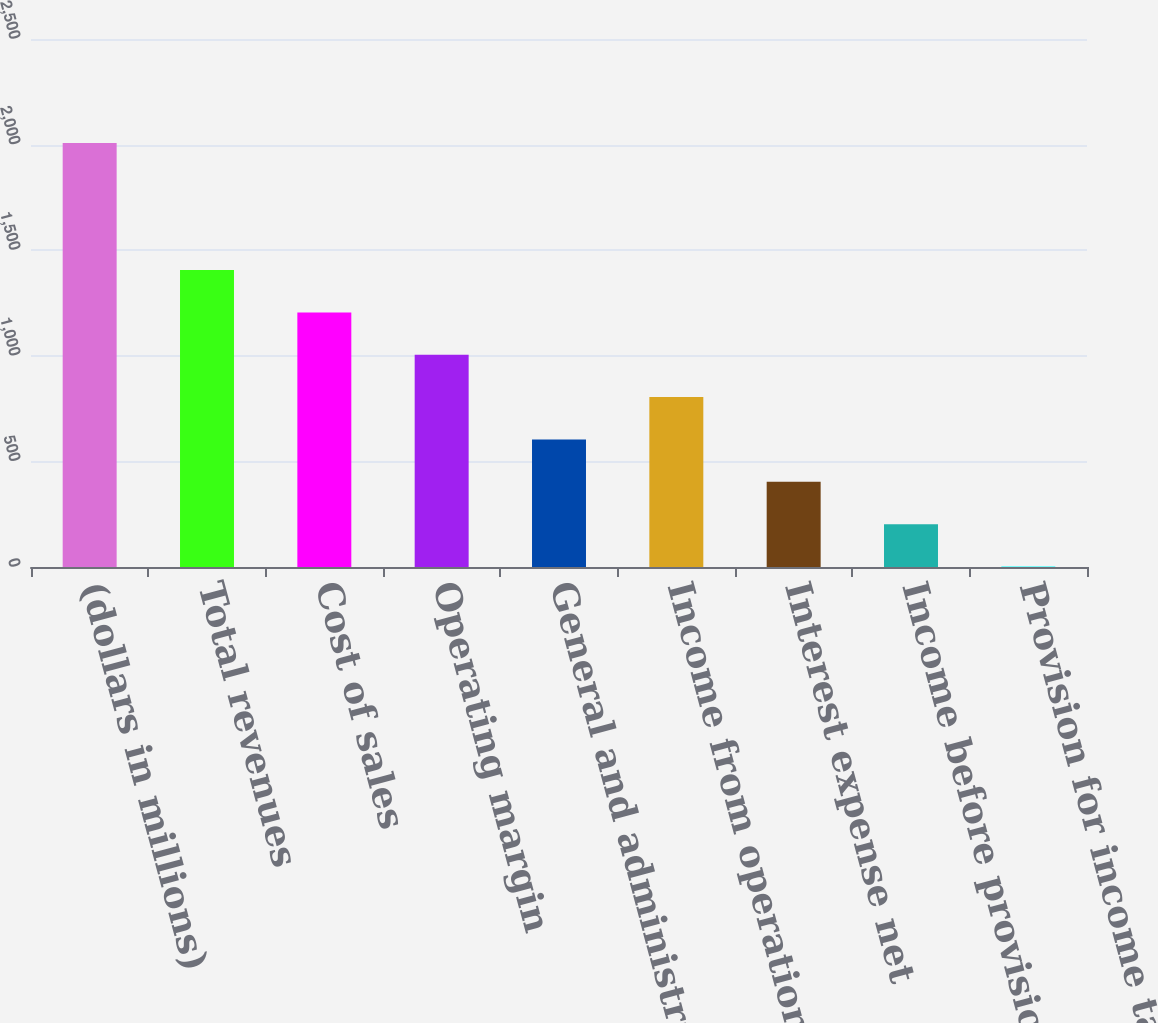Convert chart to OTSL. <chart><loc_0><loc_0><loc_500><loc_500><bar_chart><fcel>(dollars in millions)<fcel>Total revenues<fcel>Cost of sales<fcel>Operating margin<fcel>General and administrative<fcel>Income from operations<fcel>Interest expense net<fcel>Income before provision for<fcel>Provision for income taxes<nl><fcel>2008<fcel>1406.2<fcel>1205.6<fcel>1005<fcel>603.8<fcel>804.4<fcel>403.2<fcel>202.6<fcel>2<nl></chart> 